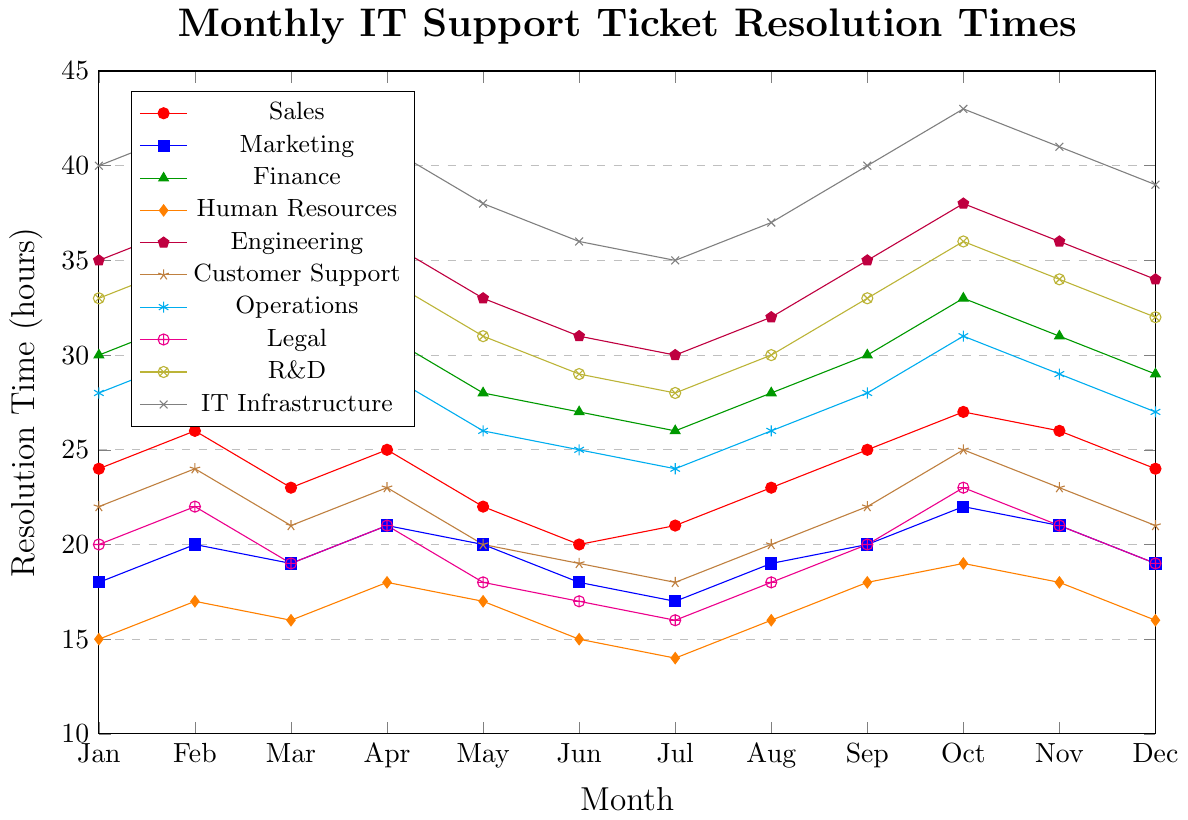What is the overall trend for IT Infrastructure's resolution time from January to December? To determine the trend, observe the line representing IT Infrastructure over the months. The line starts at 40 in January, rises to 42 in February, fluctuates through the year, and ultimately reaches 39 in December. Despite monthly variations, the general pattern indicates a high value with a slight decrease by December.
Answer: Overall, fluctuating high values with a slight decrease Which department had the lowest resolution time in July? To find the department with the lowest resolution time in July, observe and compare the resolution times for each department in July on the chart. Human Resources had the lowest value, indicated by the smallest point among the lines for that month at 14 hours.
Answer: Human Resources Compare the resolution times for Finance and Operations in October. Which one is higher? Look at the data points for Finance and Operations for the month of October. The data point for Finance is 33, and for Operations, it is 31. Therefore, Finance has a higher resolution time in October.
Answer: Finance How many departments had resolution times below 30 hours in December? Review each department's resolution time for December and count those below 30 hours. Sales (24), Marketing (19), Human Resources (16), Customer Support (21), and Legal (19) all had times below 30 hours. So, there are 5 departments.
Answer: 5 departments What is the average resolution time for Engineering from June to September? First, sum the resolution times for Engineering from June to September: 31 (June) + 30 (July) + 32 (August) + 35 (September) = 128. Then, find the average by dividing the sum by the number of months: 128 / 4 = 32.
Answer: 32 hours Which department showed the most improvement from January to December? Improvement is determined by the decrease in resolution time from January to December. Compare the January and December values for each department. Legal improved the most from 20 in January to 19 in December, with a change of -1.
Answer: Legal What is the combined resolution time for Customer Support and Sales in March? Add the resolution times of Customer Support and Sales in March. Customer Support is at 21, and Sales is at 23. Therefore, the combined resolution time is 21 + 23 = 44.
Answer: 44 hours Which months did Marketing have the lowest and highest resolution times? Observe the line representing Marketing. The lowest point is in July at 17 hours, and the highest points are in February and October at 22 hours.
Answer: Lowest: July, Highest: October & February Compare the pattern of resolution times between R&D and Engineering. Which department had more fluctuations? Analyze the lines for R&D and Engineering. Both fluctuate, but Engineering shows higher variance with larger differences between consecutive months, e.g., from May (33) to June (31) and June (31) to July (30), while R&D has smoother transitions.
Answer: Engineering What is the median resolution time for Operations over the year? List the resolution times for Operations in ascending order: 24 (Jul), 25 (Jun), 26 (Aug), 26 (May), 27 (Mar), 27 (Dec), 28 (Jan), 28 (Sep), 29 (Apr), 29 (Nov), 30 (Feb), 31 (Oct). The median value is the average of 6th and 7th values: (27 + 27) / 2 = 27.
Answer: 27 hours 